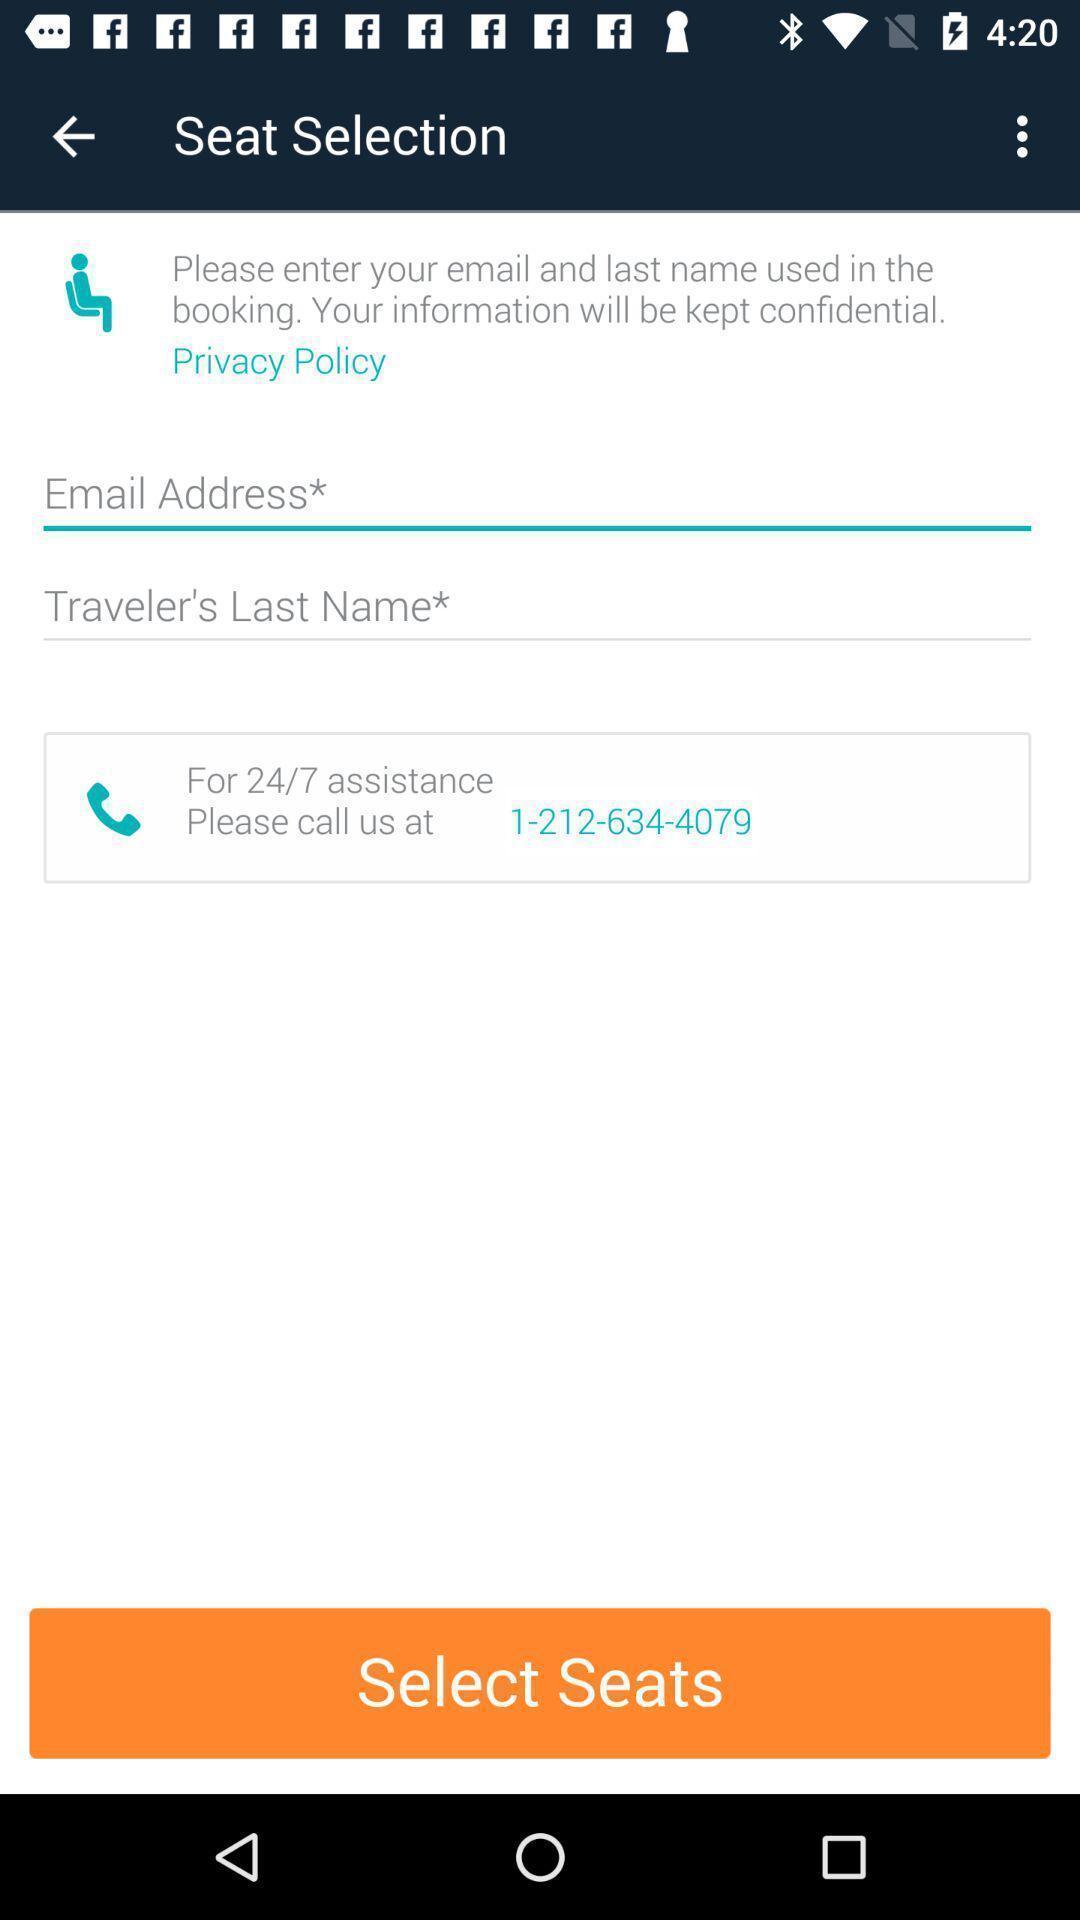Describe the key features of this screenshot. Page to select the seats in a booking application. 